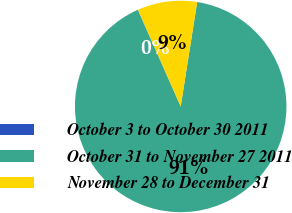Convert chart to OTSL. <chart><loc_0><loc_0><loc_500><loc_500><pie_chart><fcel>October 3 to October 30 2011<fcel>October 31 to November 27 2011<fcel>November 28 to December 31<nl><fcel>0.03%<fcel>90.86%<fcel>9.11%<nl></chart> 